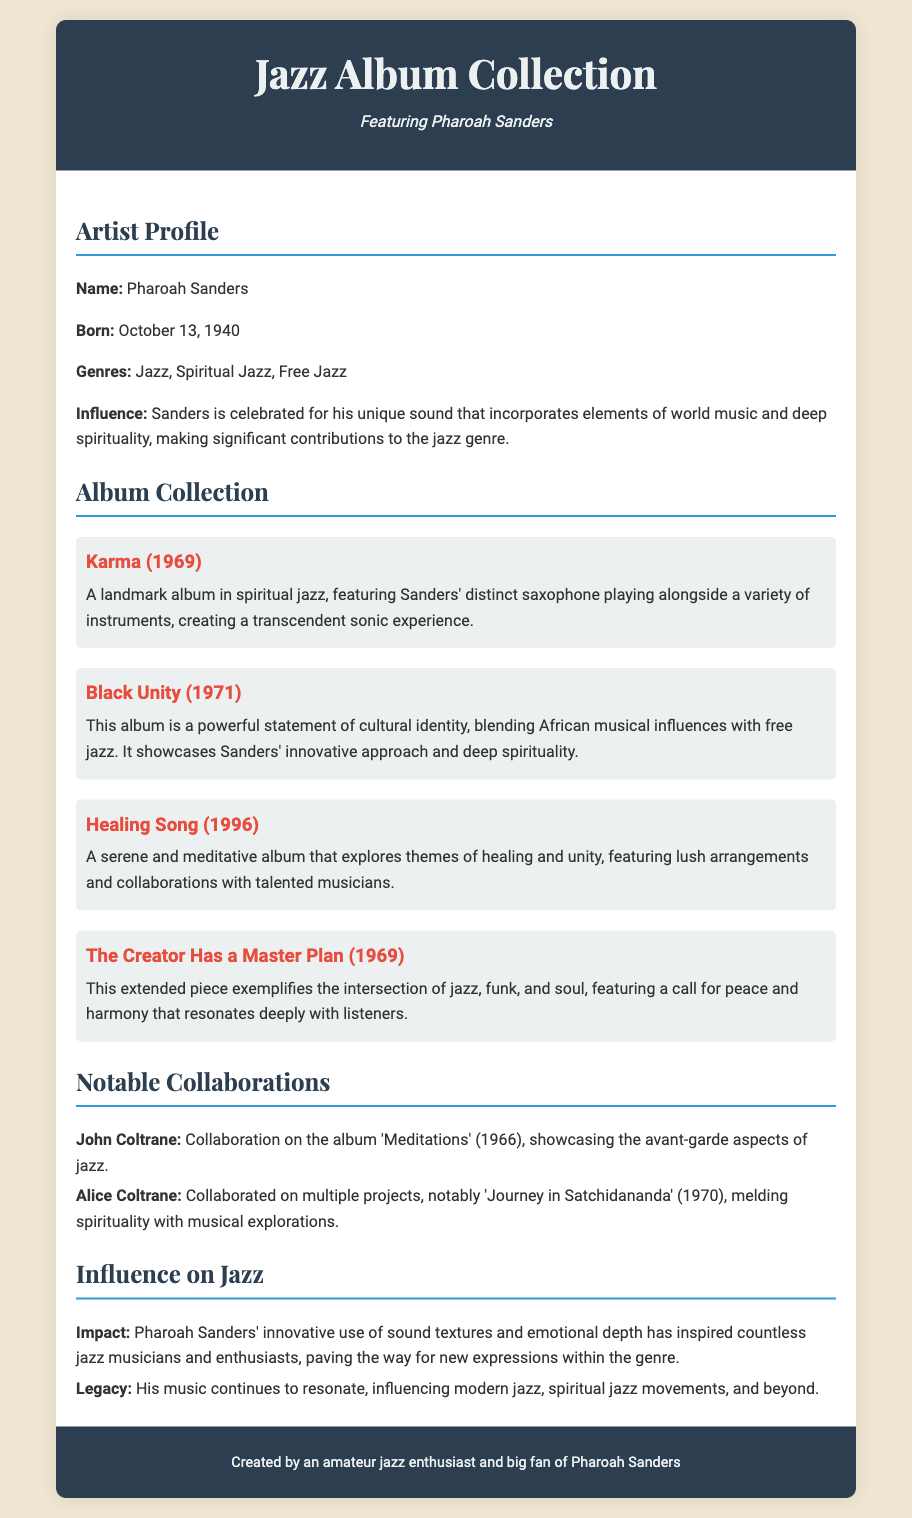What is the birth date of Pharoah Sanders? The document states that Pharoah Sanders was born on October 13, 1940.
Answer: October 13, 1940 What is a genre associated with Pharoah Sanders? The document lists the genres associated with Pharoah Sanders, which include Jazz, Spiritual Jazz, and Free Jazz.
Answer: Jazz Which album is described as a landmark in spiritual jazz? The document identifies "Karma (1969)" as a landmark album in spiritual jazz.
Answer: Karma (1969) Who collaborated with Pharoah Sanders on 'Meditations'? The document mentions John Coltrane as a collaborator on the album 'Meditations' (1966).
Answer: John Coltrane What significant theme is explored in "Healing Song"? The document notes that "Healing Song (1996)" explores themes of healing and unity.
Answer: Healing and unity What impact did Pharoah Sanders have on jazz? The document states that Pharoah Sanders' innovative use of sound textures and emotional depth has inspired countless jazz musicians and enthusiasts.
Answer: Inspired countless musicians What does "The Creator Has a Master Plan" reflect on? The document describes "The Creator Has a Master Plan (1969)" as exemplifying the intersection of jazz, funk, and soul, and featuring a call for peace and harmony.
Answer: Peace and harmony What is included in the album collection section? The document provides descriptions of various albums, including "Karma," "Black Unity," "Healing Song," and "The Creator Has a Master Plan."
Answer: Descriptions of albums What type of document is this? The document is a resume that summarizes a jazz album collection, focusing on Pharoah Sanders.
Answer: Resume 